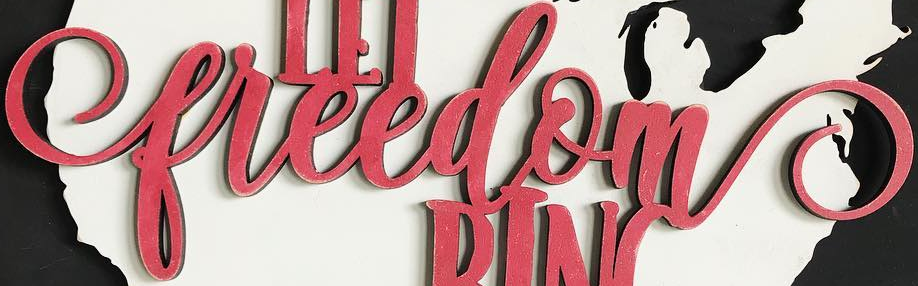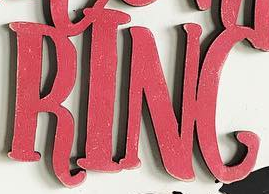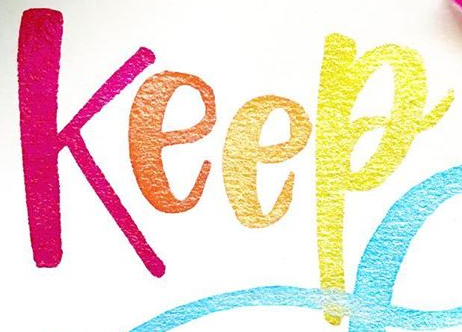Transcribe the words shown in these images in order, separated by a semicolon. freedom; RING; Keep 